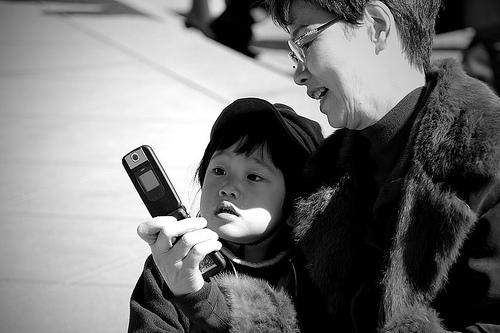What is she doing with the child?

Choices:
A) holding captive
B) teaching reading
C) feeding them
D) showing phone showing phone 